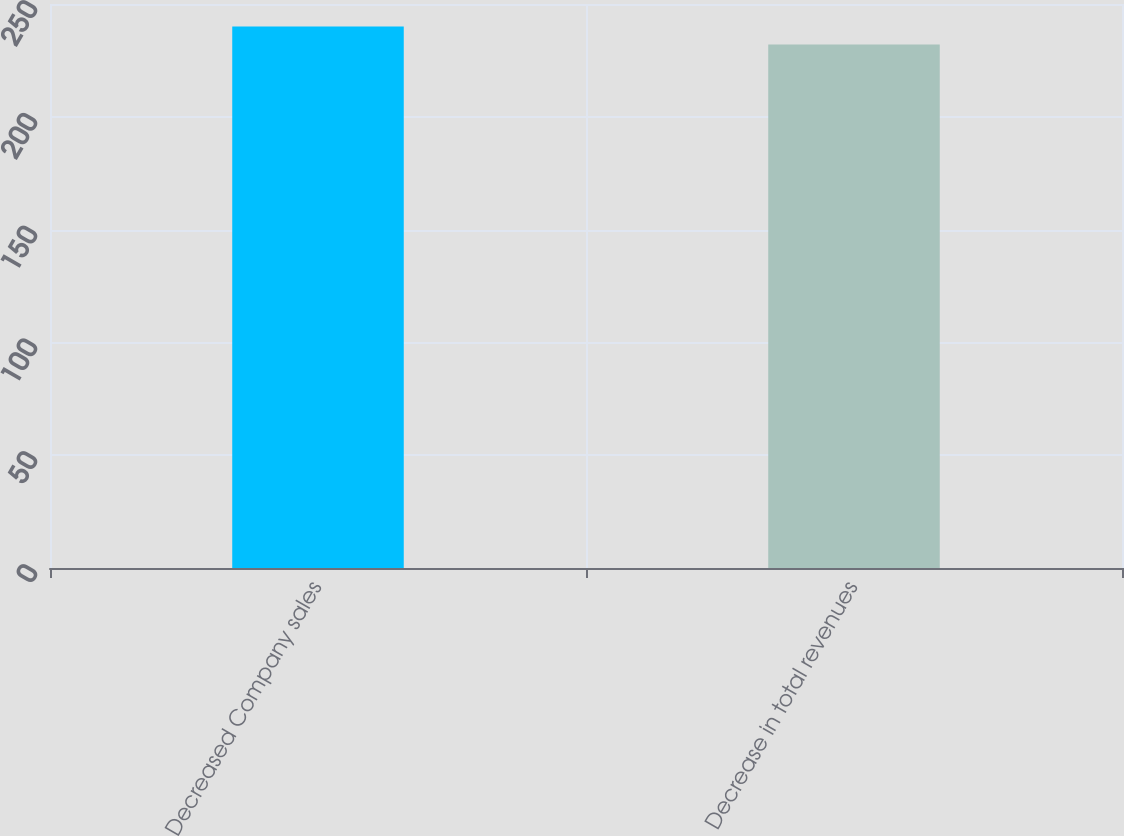Convert chart. <chart><loc_0><loc_0><loc_500><loc_500><bar_chart><fcel>Decreased Company sales<fcel>Decrease in total revenues<nl><fcel>240<fcel>232<nl></chart> 